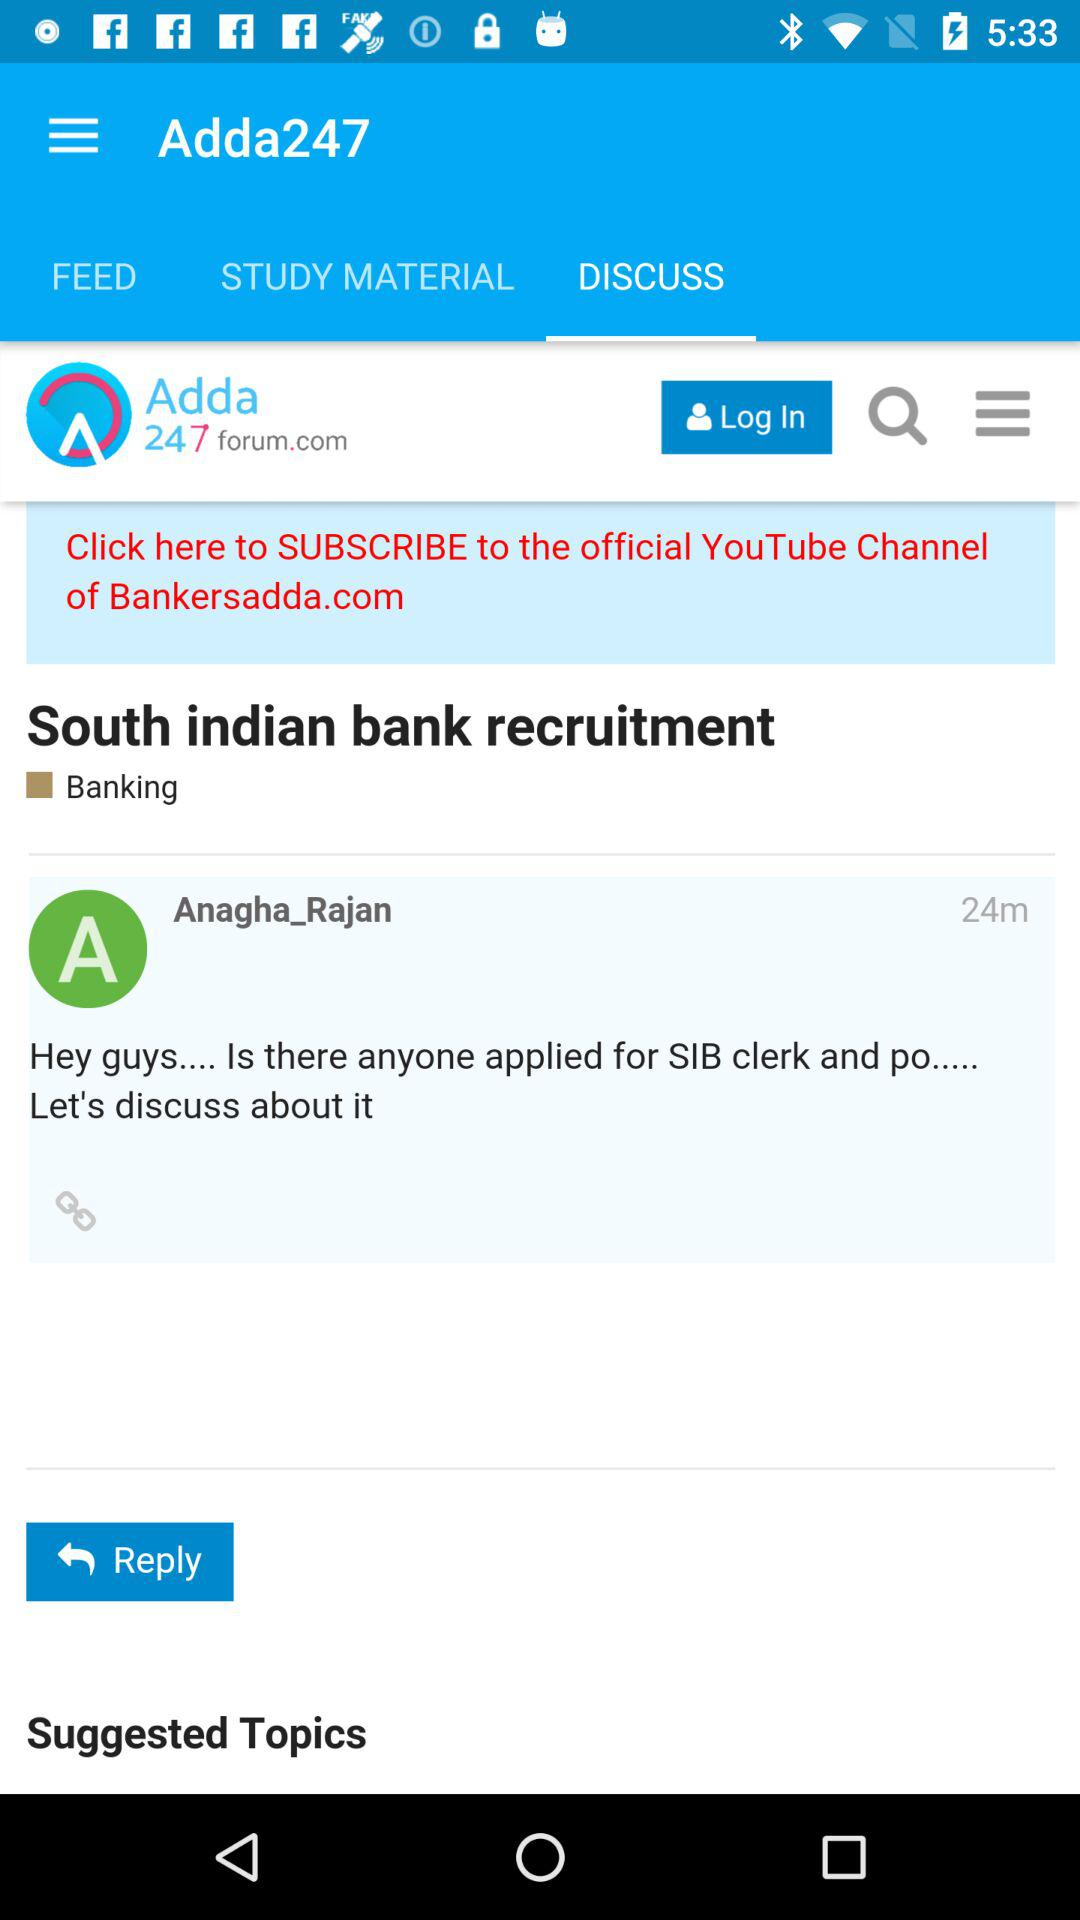What is the name of the person who commented? The name of the person is "Anagha_Rajan". 